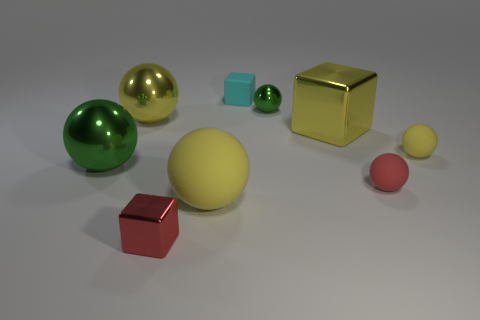What number of large yellow balls have the same material as the tiny cyan cube?
Your response must be concise. 1. How many small green objects are there?
Offer a very short reply. 1. There is a tiny thing that is in front of the tiny red matte thing; is it the same color as the large shiny thing in front of the small yellow matte ball?
Offer a terse response. No. How many green spheres are in front of the tiny yellow rubber sphere?
Your answer should be very brief. 1. There is a tiny sphere that is the same color as the tiny shiny cube; what is it made of?
Your answer should be compact. Rubber. Is there a big gray thing that has the same shape as the tiny yellow object?
Provide a succinct answer. No. Is the material of the green sphere that is to the left of the small red block the same as the yellow block that is on the right side of the cyan matte object?
Ensure brevity in your answer.  Yes. There is a metal block that is in front of the green metal sphere on the left side of the metal ball that is right of the small cyan object; what size is it?
Keep it short and to the point. Small. There is a green ball that is the same size as the cyan rubber thing; what is it made of?
Offer a very short reply. Metal. Are there any shiny cubes that have the same size as the cyan matte thing?
Your answer should be compact. Yes. 